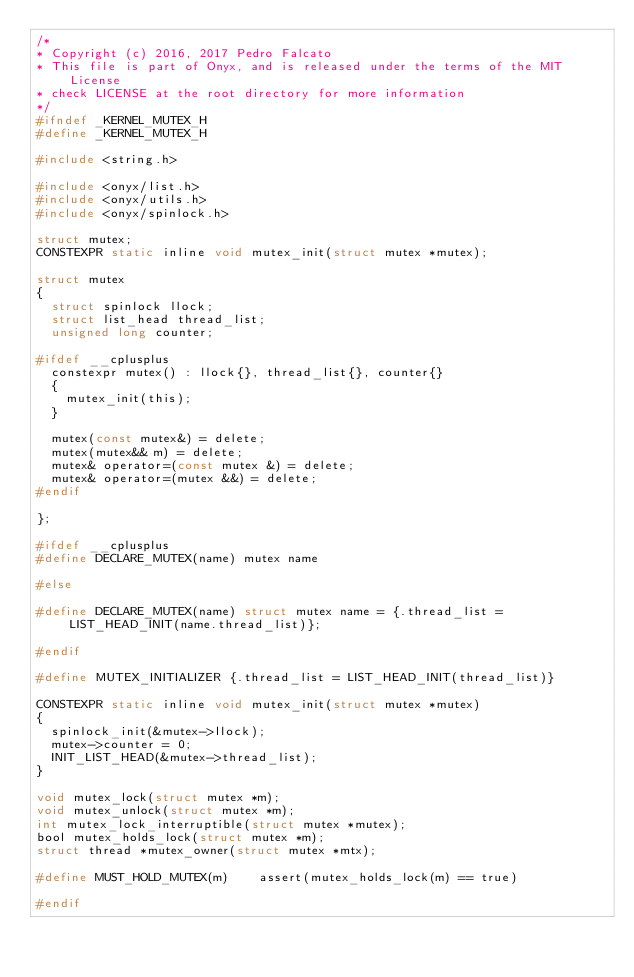<code> <loc_0><loc_0><loc_500><loc_500><_C_>/*
* Copyright (c) 2016, 2017 Pedro Falcato
* This file is part of Onyx, and is released under the terms of the MIT License
* check LICENSE at the root directory for more information
*/
#ifndef _KERNEL_MUTEX_H
#define _KERNEL_MUTEX_H

#include <string.h>

#include <onyx/list.h>
#include <onyx/utils.h>
#include <onyx/spinlock.h>

struct mutex;
CONSTEXPR static inline void mutex_init(struct mutex *mutex);

struct mutex
{
	struct spinlock llock;
	struct list_head thread_list;
	unsigned long counter;

#ifdef __cplusplus
	constexpr mutex() : llock{}, thread_list{}, counter{}
	{
		mutex_init(this);
	}

	mutex(const mutex&) = delete;
	mutex(mutex&& m) = delete;
	mutex& operator=(const mutex &) = delete;
	mutex& operator=(mutex &&) = delete;
#endif

};

#ifdef __cplusplus
#define DECLARE_MUTEX(name) mutex name

#else

#define DECLARE_MUTEX(name)	struct mutex name = {.thread_list = LIST_HEAD_INIT(name.thread_list)};

#endif

#define MUTEX_INITIALIZER {.thread_list = LIST_HEAD_INIT(thread_list)}

CONSTEXPR static inline void mutex_init(struct mutex *mutex)
{
	spinlock_init(&mutex->llock);
	mutex->counter = 0;
	INIT_LIST_HEAD(&mutex->thread_list);
}

void mutex_lock(struct mutex *m);
void mutex_unlock(struct mutex *m);
int mutex_lock_interruptible(struct mutex *mutex);
bool mutex_holds_lock(struct mutex *m);
struct thread *mutex_owner(struct mutex *mtx);

#define MUST_HOLD_MUTEX(m)		assert(mutex_holds_lock(m) == true)

#endif
</code> 